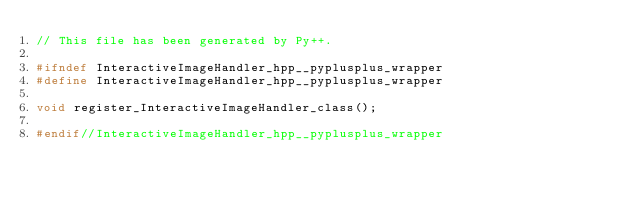Convert code to text. <code><loc_0><loc_0><loc_500><loc_500><_C++_>// This file has been generated by Py++.

#ifndef InteractiveImageHandler_hpp__pyplusplus_wrapper
#define InteractiveImageHandler_hpp__pyplusplus_wrapper

void register_InteractiveImageHandler_class();

#endif//InteractiveImageHandler_hpp__pyplusplus_wrapper
</code> 